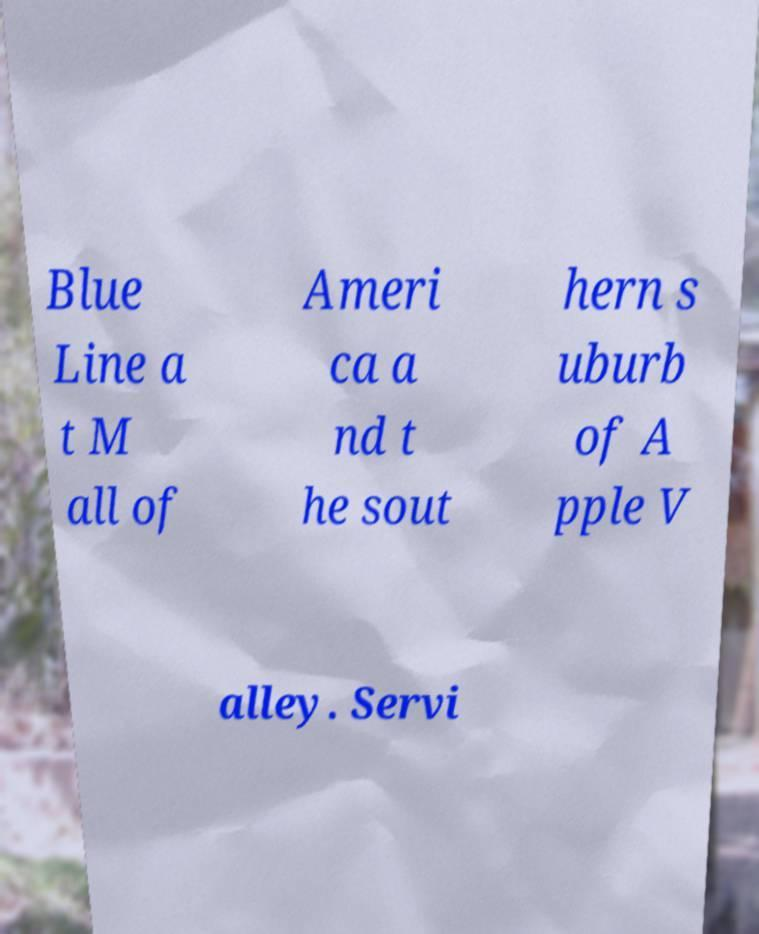Can you read and provide the text displayed in the image?This photo seems to have some interesting text. Can you extract and type it out for me? Blue Line a t M all of Ameri ca a nd t he sout hern s uburb of A pple V alley. Servi 